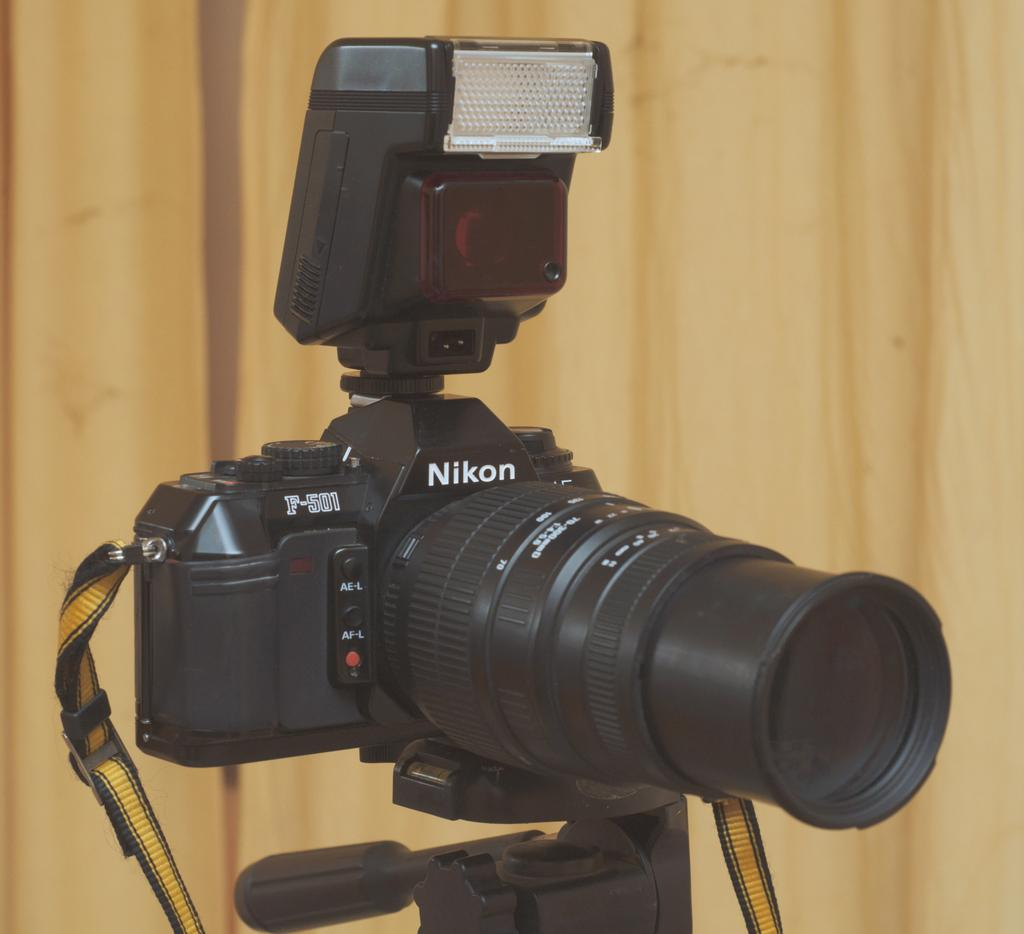What is the main subject in the center of the image? There is a camera in the center of the image. How is the camera positioned in the image? The camera is on a stand. What can be seen in the background of the image? There is a wall visible in the background of the image. What book is the camera talking about in the image? There is no book or talking in the image; it only features a camera on a stand with a wall in the background. 